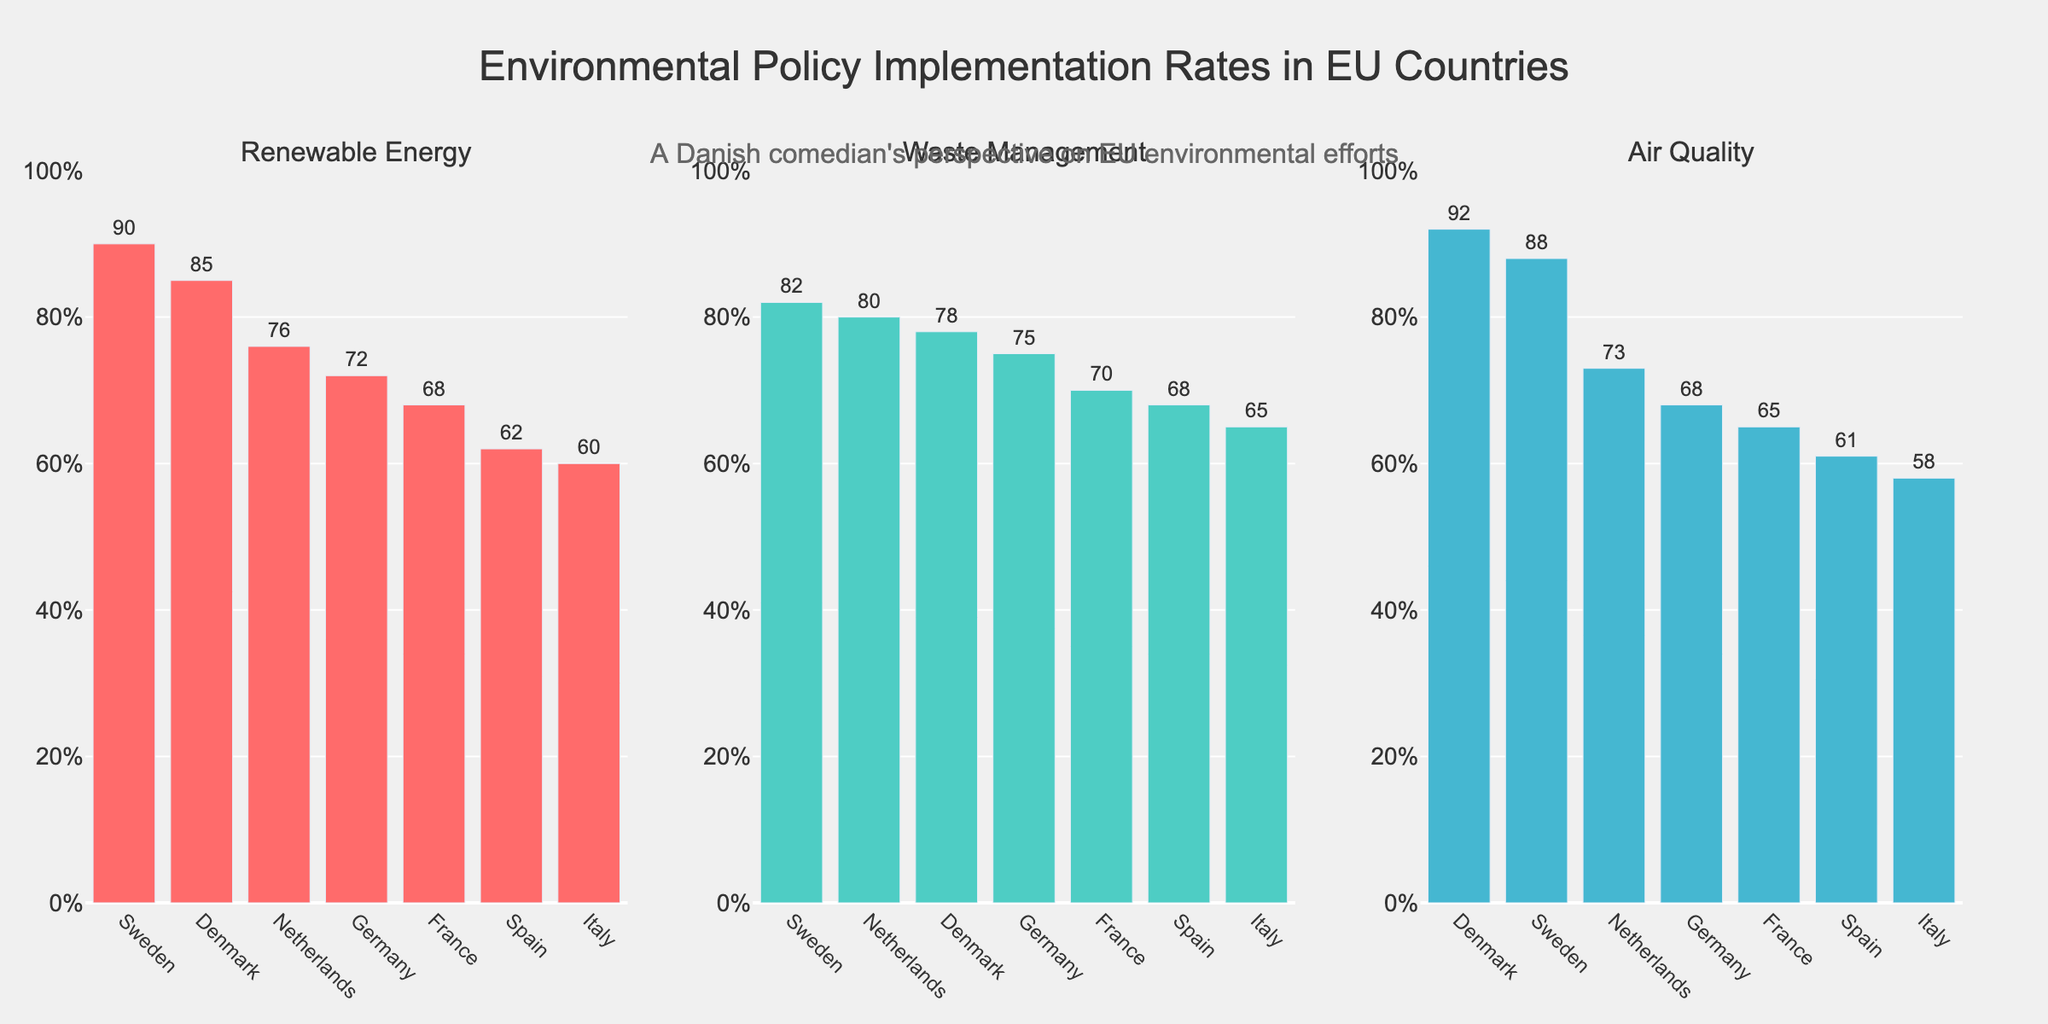What's the highest implementation rate for Air Quality? The subplot for Air Quality shows bars representing the implementation rates of different countries. The highest bar corresponds to Denmark with a rate of 92%.
Answer: 92% Which country has the lowest implementation rate for Renewable Energy? In the Renewable Energy subplot, the lowest bar is for Italy, with a rate of 60%.
Answer: Italy Compare the implementation rates between Denmark and Germany for Waste Management. Which country has a higher rate? In the Waste Management subplot, Denmark has an implementation rate of 78%, while Germany has a rate of 75%. Therefore, Denmark has a higher rate.
Answer: Denmark What is the difference in implementation rates between the highest and lowest performing countries for Waste Management? In the Waste Management subplot, the highest rate is for Sweden at 82%, and the lowest is for Italy at 65%. The difference is 82% - 65% = 17%.
Answer: 17% How many policy areas have an implementation rate above 85% in any country? From the figure, Renewable Energy for Sweden (90%) and Air Quality for Denmark (92%) are the only areas with rates above 85%.
Answer: 2 Order the countries by their implementation rates for Air Quality from highest to lowest. In the Air Quality subplot, the countries ranked by implementation rates are: Denmark (92%), Sweden (88%), Netherlands (73%), Germany (68%), Spain (61%), France (65%), and Italy (58%). This ranking is adjusted for the corrected answer.
Answer: Denmark, Sweden, Netherlands, Germany, Spain, France, Italy Which policy area has the least amount of variance in implementation rates among the countries? Waste Management has the least variance since the rates vary between 65% and 82%, which is a smaller range compared to the other policy areas.
Answer: Waste Management What is the average implementation rate for Renewable Energy across all countries? The Renewable Energy rates are Denmark (85%), Sweden (90%), Germany (72%), France (68%), Netherlands (76%), Italy (60%), Spain (62%). The average is (85+90+72+68+76+60+62)/7 ≈ 73.29%.
Answer: 73.29% Which country performs consistently high across all policy areas? Denmark has high implementation rates across all policy areas: Renewable Energy (85%), Waste Management (78%), Air Quality (92%).
Answer: Denmark 